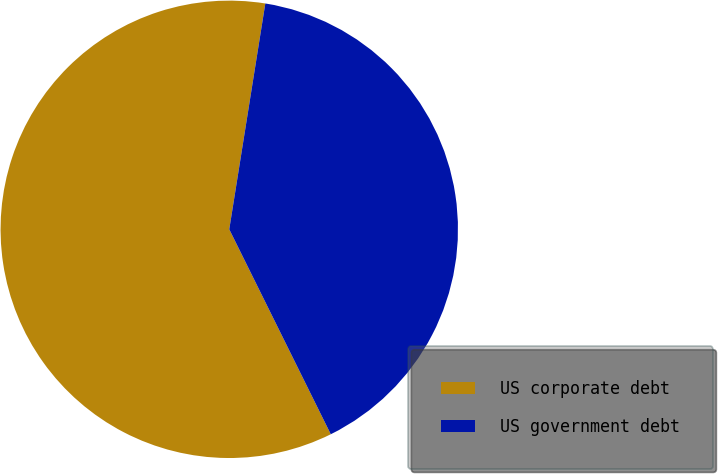<chart> <loc_0><loc_0><loc_500><loc_500><pie_chart><fcel>US corporate debt<fcel>US government debt<nl><fcel>59.84%<fcel>40.16%<nl></chart> 